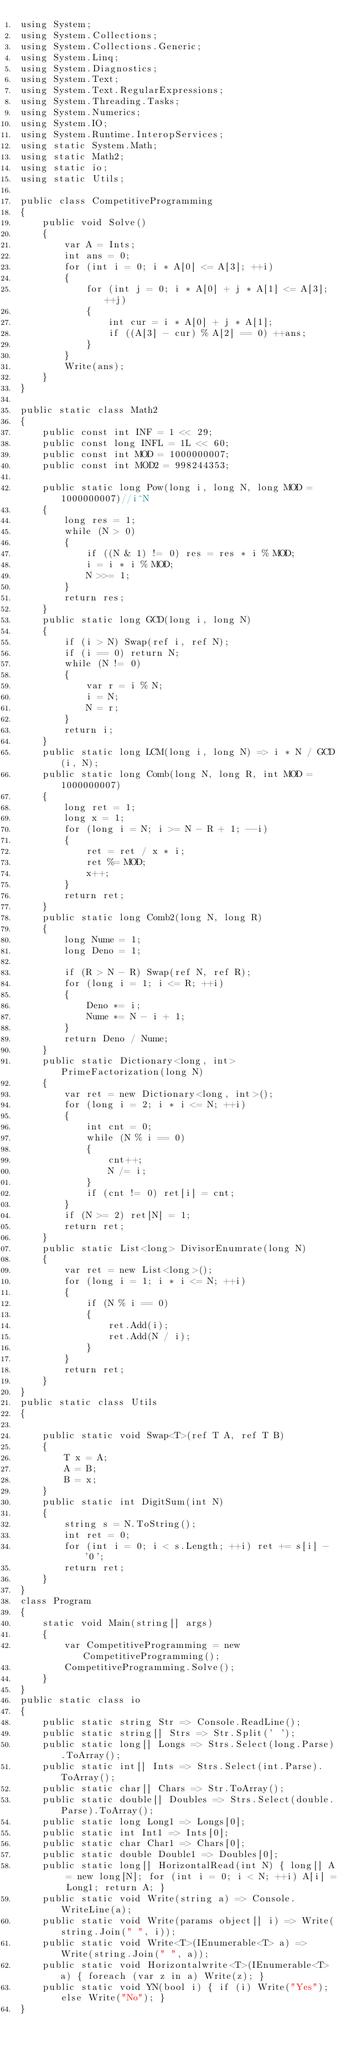Convert code to text. <code><loc_0><loc_0><loc_500><loc_500><_C#_>using System;
using System.Collections;
using System.Collections.Generic;
using System.Linq;
using System.Diagnostics;
using System.Text;
using System.Text.RegularExpressions;
using System.Threading.Tasks;
using System.Numerics;
using System.IO;
using System.Runtime.InteropServices;
using static System.Math;
using static Math2;
using static io;
using static Utils;

public class CompetitiveProgramming
{
    public void Solve()
    {
        var A = Ints;
        int ans = 0;
        for (int i = 0; i * A[0] <= A[3]; ++i)
        {
            for (int j = 0; i * A[0] + j * A[1] <= A[3]; ++j)
            {
                int cur = i * A[0] + j * A[1];
                if ((A[3] - cur) % A[2] == 0) ++ans;
            }
        }
        Write(ans);
    }
}

public static class Math2
{
    public const int INF = 1 << 29;
    public const long INFL = 1L << 60;
    public const int MOD = 1000000007;
    public const int MOD2 = 998244353;

    public static long Pow(long i, long N, long MOD = 1000000007)//i^N
    {
        long res = 1;
        while (N > 0)
        {
            if ((N & 1) != 0) res = res * i % MOD;
            i = i * i % MOD;
            N >>= 1;
        }
        return res;
    }
    public static long GCD(long i, long N)
    {
        if (i > N) Swap(ref i, ref N);
        if (i == 0) return N;
        while (N != 0)
        {
            var r = i % N;
            i = N;
            N = r;
        }
        return i;
    }
    public static long LCM(long i, long N) => i * N / GCD(i, N);
    public static long Comb(long N, long R, int MOD = 1000000007)
    {
        long ret = 1;
        long x = 1;
        for (long i = N; i >= N - R + 1; --i)
        {
            ret = ret / x * i;
            ret %= MOD;
            x++;
        }
        return ret;
    }
    public static long Comb2(long N, long R)
    {
        long Nume = 1;
        long Deno = 1;

        if (R > N - R) Swap(ref N, ref R);
        for (long i = 1; i <= R; ++i)
        {
            Deno *= i;
            Nume *= N - i + 1;
        }
        return Deno / Nume;
    }
    public static Dictionary<long, int> PrimeFactorization(long N)
    {
        var ret = new Dictionary<long, int>();
        for (long i = 2; i * i <= N; ++i)
        {
            int cnt = 0;
            while (N % i == 0)
            {
                cnt++;
                N /= i;
            }
            if (cnt != 0) ret[i] = cnt;
        }
        if (N >= 2) ret[N] = 1;
        return ret;
    }
    public static List<long> DivisorEnumrate(long N)
    {
        var ret = new List<long>();
        for (long i = 1; i * i <= N; ++i)
        {
            if (N % i == 0)
            {
                ret.Add(i);
                ret.Add(N / i);
            }
        }
        return ret;
    }
}
public static class Utils
{

    public static void Swap<T>(ref T A, ref T B)
    {
        T x = A;
        A = B;
        B = x;
    }
    public static int DigitSum(int N)
    {
        string s = N.ToString();
        int ret = 0;
        for (int i = 0; i < s.Length; ++i) ret += s[i] - '0';
        return ret;
    }
}
class Program
{
    static void Main(string[] args)
    {
        var CompetitiveProgramming = new CompetitiveProgramming();
        CompetitiveProgramming.Solve();
    }
}
public static class io
{
    public static string Str => Console.ReadLine();
    public static string[] Strs => Str.Split(' ');
    public static long[] Longs => Strs.Select(long.Parse).ToArray();
    public static int[] Ints => Strs.Select(int.Parse).ToArray();
    public static char[] Chars => Str.ToArray();
    public static double[] Doubles => Strs.Select(double.Parse).ToArray();
    public static long Long1 => Longs[0];
    public static int Int1 => Ints[0];
    public static char Char1 => Chars[0];
    public static double Double1 => Doubles[0];
    public static long[] HorizontalRead(int N) { long[] A = new long[N]; for (int i = 0; i < N; ++i) A[i] = Long1; return A; }
    public static void Write(string a) => Console.WriteLine(a);
    public static void Write(params object[] i) => Write(string.Join(" ", i));
    public static void Write<T>(IEnumerable<T> a) => Write(string.Join(" ", a));
    public static void Horizontalwrite<T>(IEnumerable<T> a) { foreach (var z in a) Write(z); }
    public static void YN(bool i) { if (i) Write("Yes"); else Write("No"); }
}
</code> 